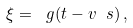<formula> <loc_0><loc_0><loc_500><loc_500>\xi = \ g ( t - v \ s ) \, ,</formula> 